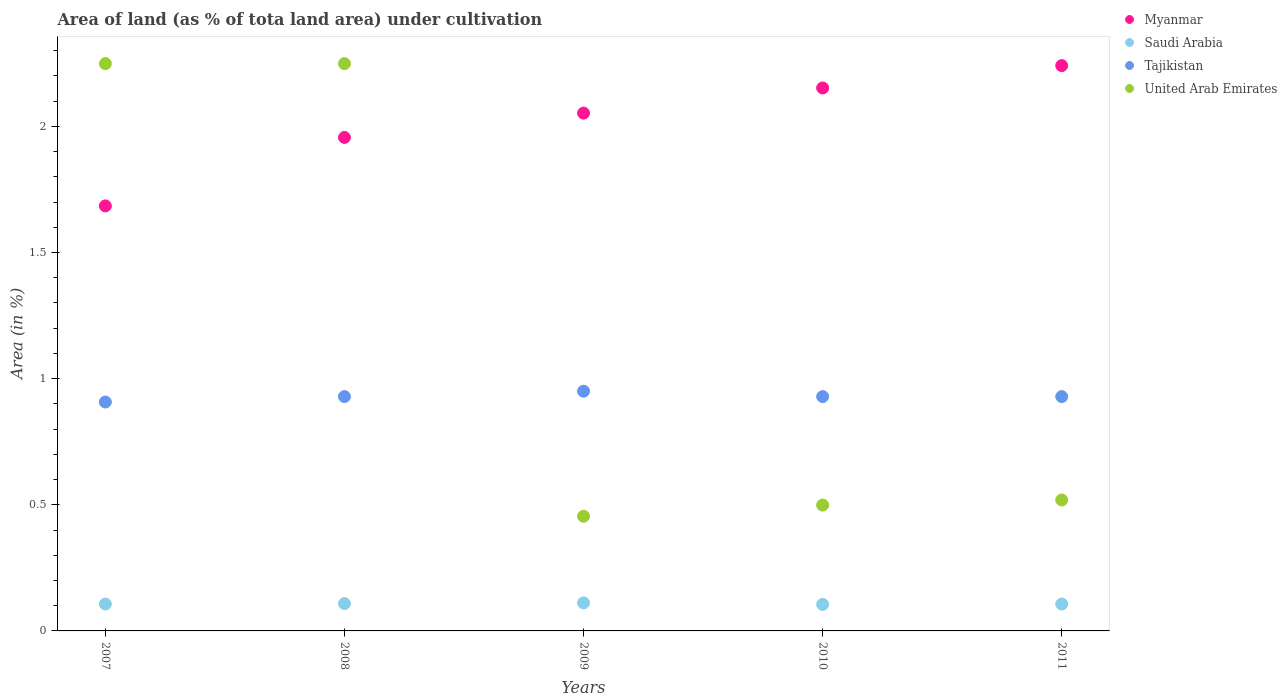What is the percentage of land under cultivation in Myanmar in 2011?
Make the answer very short. 2.24. Across all years, what is the maximum percentage of land under cultivation in Tajikistan?
Your response must be concise. 0.95. Across all years, what is the minimum percentage of land under cultivation in Saudi Arabia?
Make the answer very short. 0.11. In which year was the percentage of land under cultivation in Myanmar minimum?
Ensure brevity in your answer.  2007. What is the total percentage of land under cultivation in Tajikistan in the graph?
Keep it short and to the point. 4.64. What is the difference between the percentage of land under cultivation in Myanmar in 2008 and that in 2010?
Give a very brief answer. -0.2. What is the difference between the percentage of land under cultivation in Tajikistan in 2010 and the percentage of land under cultivation in United Arab Emirates in 2007?
Offer a very short reply. -1.32. What is the average percentage of land under cultivation in Tajikistan per year?
Offer a terse response. 0.93. In the year 2007, what is the difference between the percentage of land under cultivation in United Arab Emirates and percentage of land under cultivation in Myanmar?
Your answer should be very brief. 0.56. In how many years, is the percentage of land under cultivation in Saudi Arabia greater than 1.3 %?
Provide a succinct answer. 0. What is the ratio of the percentage of land under cultivation in Saudi Arabia in 2008 to that in 2011?
Give a very brief answer. 1.02. What is the difference between the highest and the second highest percentage of land under cultivation in Tajikistan?
Make the answer very short. 0.02. What is the difference between the highest and the lowest percentage of land under cultivation in Tajikistan?
Your response must be concise. 0.04. In how many years, is the percentage of land under cultivation in Saudi Arabia greater than the average percentage of land under cultivation in Saudi Arabia taken over all years?
Provide a short and direct response. 2. Is the sum of the percentage of land under cultivation in United Arab Emirates in 2009 and 2011 greater than the maximum percentage of land under cultivation in Myanmar across all years?
Give a very brief answer. No. Is it the case that in every year, the sum of the percentage of land under cultivation in Tajikistan and percentage of land under cultivation in Saudi Arabia  is greater than the sum of percentage of land under cultivation in United Arab Emirates and percentage of land under cultivation in Myanmar?
Your answer should be very brief. No. Is the percentage of land under cultivation in Myanmar strictly less than the percentage of land under cultivation in Saudi Arabia over the years?
Ensure brevity in your answer.  No. How many years are there in the graph?
Keep it short and to the point. 5. Are the values on the major ticks of Y-axis written in scientific E-notation?
Offer a terse response. No. Where does the legend appear in the graph?
Ensure brevity in your answer.  Top right. How many legend labels are there?
Your answer should be very brief. 4. How are the legend labels stacked?
Your response must be concise. Vertical. What is the title of the graph?
Ensure brevity in your answer.  Area of land (as % of tota land area) under cultivation. What is the label or title of the Y-axis?
Keep it short and to the point. Area (in %). What is the Area (in %) in Myanmar in 2007?
Your response must be concise. 1.68. What is the Area (in %) of Saudi Arabia in 2007?
Your response must be concise. 0.11. What is the Area (in %) in Tajikistan in 2007?
Keep it short and to the point. 0.91. What is the Area (in %) of United Arab Emirates in 2007?
Ensure brevity in your answer.  2.25. What is the Area (in %) of Myanmar in 2008?
Ensure brevity in your answer.  1.96. What is the Area (in %) in Saudi Arabia in 2008?
Give a very brief answer. 0.11. What is the Area (in %) in Tajikistan in 2008?
Your answer should be compact. 0.93. What is the Area (in %) of United Arab Emirates in 2008?
Your response must be concise. 2.25. What is the Area (in %) in Myanmar in 2009?
Provide a succinct answer. 2.05. What is the Area (in %) in Saudi Arabia in 2009?
Give a very brief answer. 0.11. What is the Area (in %) of Tajikistan in 2009?
Provide a short and direct response. 0.95. What is the Area (in %) in United Arab Emirates in 2009?
Your response must be concise. 0.45. What is the Area (in %) in Myanmar in 2010?
Offer a very short reply. 2.15. What is the Area (in %) of Saudi Arabia in 2010?
Make the answer very short. 0.11. What is the Area (in %) of Tajikistan in 2010?
Offer a very short reply. 0.93. What is the Area (in %) in United Arab Emirates in 2010?
Offer a very short reply. 0.5. What is the Area (in %) in Myanmar in 2011?
Your answer should be compact. 2.24. What is the Area (in %) in Saudi Arabia in 2011?
Offer a terse response. 0.11. What is the Area (in %) in Tajikistan in 2011?
Your response must be concise. 0.93. What is the Area (in %) of United Arab Emirates in 2011?
Provide a succinct answer. 0.52. Across all years, what is the maximum Area (in %) of Myanmar?
Offer a very short reply. 2.24. Across all years, what is the maximum Area (in %) of Saudi Arabia?
Give a very brief answer. 0.11. Across all years, what is the maximum Area (in %) of Tajikistan?
Offer a very short reply. 0.95. Across all years, what is the maximum Area (in %) in United Arab Emirates?
Your response must be concise. 2.25. Across all years, what is the minimum Area (in %) in Myanmar?
Your answer should be very brief. 1.68. Across all years, what is the minimum Area (in %) in Saudi Arabia?
Your answer should be compact. 0.11. Across all years, what is the minimum Area (in %) of Tajikistan?
Offer a terse response. 0.91. Across all years, what is the minimum Area (in %) in United Arab Emirates?
Offer a very short reply. 0.45. What is the total Area (in %) of Myanmar in the graph?
Your answer should be compact. 10.09. What is the total Area (in %) in Saudi Arabia in the graph?
Provide a succinct answer. 0.54. What is the total Area (in %) of Tajikistan in the graph?
Offer a very short reply. 4.64. What is the total Area (in %) in United Arab Emirates in the graph?
Offer a very short reply. 5.97. What is the difference between the Area (in %) of Myanmar in 2007 and that in 2008?
Your response must be concise. -0.27. What is the difference between the Area (in %) in Saudi Arabia in 2007 and that in 2008?
Ensure brevity in your answer.  -0. What is the difference between the Area (in %) in Tajikistan in 2007 and that in 2008?
Your answer should be compact. -0.02. What is the difference between the Area (in %) in Myanmar in 2007 and that in 2009?
Offer a very short reply. -0.37. What is the difference between the Area (in %) of Saudi Arabia in 2007 and that in 2009?
Provide a succinct answer. -0. What is the difference between the Area (in %) of Tajikistan in 2007 and that in 2009?
Make the answer very short. -0.04. What is the difference between the Area (in %) in United Arab Emirates in 2007 and that in 2009?
Make the answer very short. 1.79. What is the difference between the Area (in %) in Myanmar in 2007 and that in 2010?
Provide a short and direct response. -0.47. What is the difference between the Area (in %) in Saudi Arabia in 2007 and that in 2010?
Provide a short and direct response. 0. What is the difference between the Area (in %) of Tajikistan in 2007 and that in 2010?
Give a very brief answer. -0.02. What is the difference between the Area (in %) of United Arab Emirates in 2007 and that in 2010?
Keep it short and to the point. 1.75. What is the difference between the Area (in %) of Myanmar in 2007 and that in 2011?
Ensure brevity in your answer.  -0.56. What is the difference between the Area (in %) in Saudi Arabia in 2007 and that in 2011?
Ensure brevity in your answer.  0. What is the difference between the Area (in %) in Tajikistan in 2007 and that in 2011?
Ensure brevity in your answer.  -0.02. What is the difference between the Area (in %) of United Arab Emirates in 2007 and that in 2011?
Provide a succinct answer. 1.73. What is the difference between the Area (in %) of Myanmar in 2008 and that in 2009?
Give a very brief answer. -0.1. What is the difference between the Area (in %) in Saudi Arabia in 2008 and that in 2009?
Your answer should be very brief. -0. What is the difference between the Area (in %) of Tajikistan in 2008 and that in 2009?
Offer a terse response. -0.02. What is the difference between the Area (in %) in United Arab Emirates in 2008 and that in 2009?
Provide a short and direct response. 1.79. What is the difference between the Area (in %) of Myanmar in 2008 and that in 2010?
Offer a terse response. -0.2. What is the difference between the Area (in %) of Saudi Arabia in 2008 and that in 2010?
Your answer should be very brief. 0. What is the difference between the Area (in %) in Myanmar in 2008 and that in 2011?
Your response must be concise. -0.28. What is the difference between the Area (in %) in Saudi Arabia in 2008 and that in 2011?
Ensure brevity in your answer.  0. What is the difference between the Area (in %) of United Arab Emirates in 2008 and that in 2011?
Provide a succinct answer. 1.73. What is the difference between the Area (in %) in Myanmar in 2009 and that in 2010?
Ensure brevity in your answer.  -0.1. What is the difference between the Area (in %) of Saudi Arabia in 2009 and that in 2010?
Your answer should be very brief. 0.01. What is the difference between the Area (in %) of Tajikistan in 2009 and that in 2010?
Your response must be concise. 0.02. What is the difference between the Area (in %) in United Arab Emirates in 2009 and that in 2010?
Ensure brevity in your answer.  -0.04. What is the difference between the Area (in %) of Myanmar in 2009 and that in 2011?
Offer a terse response. -0.19. What is the difference between the Area (in %) in Saudi Arabia in 2009 and that in 2011?
Give a very brief answer. 0. What is the difference between the Area (in %) of Tajikistan in 2009 and that in 2011?
Offer a terse response. 0.02. What is the difference between the Area (in %) of United Arab Emirates in 2009 and that in 2011?
Make the answer very short. -0.06. What is the difference between the Area (in %) of Myanmar in 2010 and that in 2011?
Give a very brief answer. -0.09. What is the difference between the Area (in %) in Saudi Arabia in 2010 and that in 2011?
Provide a succinct answer. -0. What is the difference between the Area (in %) of Tajikistan in 2010 and that in 2011?
Offer a terse response. 0. What is the difference between the Area (in %) of United Arab Emirates in 2010 and that in 2011?
Your answer should be compact. -0.02. What is the difference between the Area (in %) of Myanmar in 2007 and the Area (in %) of Saudi Arabia in 2008?
Keep it short and to the point. 1.58. What is the difference between the Area (in %) in Myanmar in 2007 and the Area (in %) in Tajikistan in 2008?
Ensure brevity in your answer.  0.76. What is the difference between the Area (in %) in Myanmar in 2007 and the Area (in %) in United Arab Emirates in 2008?
Give a very brief answer. -0.56. What is the difference between the Area (in %) in Saudi Arabia in 2007 and the Area (in %) in Tajikistan in 2008?
Keep it short and to the point. -0.82. What is the difference between the Area (in %) of Saudi Arabia in 2007 and the Area (in %) of United Arab Emirates in 2008?
Give a very brief answer. -2.14. What is the difference between the Area (in %) of Tajikistan in 2007 and the Area (in %) of United Arab Emirates in 2008?
Give a very brief answer. -1.34. What is the difference between the Area (in %) in Myanmar in 2007 and the Area (in %) in Saudi Arabia in 2009?
Your response must be concise. 1.57. What is the difference between the Area (in %) of Myanmar in 2007 and the Area (in %) of Tajikistan in 2009?
Your answer should be compact. 0.73. What is the difference between the Area (in %) of Myanmar in 2007 and the Area (in %) of United Arab Emirates in 2009?
Your answer should be very brief. 1.23. What is the difference between the Area (in %) of Saudi Arabia in 2007 and the Area (in %) of Tajikistan in 2009?
Keep it short and to the point. -0.84. What is the difference between the Area (in %) of Saudi Arabia in 2007 and the Area (in %) of United Arab Emirates in 2009?
Provide a succinct answer. -0.35. What is the difference between the Area (in %) in Tajikistan in 2007 and the Area (in %) in United Arab Emirates in 2009?
Offer a very short reply. 0.45. What is the difference between the Area (in %) of Myanmar in 2007 and the Area (in %) of Saudi Arabia in 2010?
Offer a terse response. 1.58. What is the difference between the Area (in %) in Myanmar in 2007 and the Area (in %) in Tajikistan in 2010?
Your answer should be compact. 0.76. What is the difference between the Area (in %) in Myanmar in 2007 and the Area (in %) in United Arab Emirates in 2010?
Provide a succinct answer. 1.19. What is the difference between the Area (in %) of Saudi Arabia in 2007 and the Area (in %) of Tajikistan in 2010?
Offer a terse response. -0.82. What is the difference between the Area (in %) in Saudi Arabia in 2007 and the Area (in %) in United Arab Emirates in 2010?
Your response must be concise. -0.39. What is the difference between the Area (in %) of Tajikistan in 2007 and the Area (in %) of United Arab Emirates in 2010?
Your response must be concise. 0.41. What is the difference between the Area (in %) of Myanmar in 2007 and the Area (in %) of Saudi Arabia in 2011?
Keep it short and to the point. 1.58. What is the difference between the Area (in %) of Myanmar in 2007 and the Area (in %) of Tajikistan in 2011?
Your answer should be very brief. 0.76. What is the difference between the Area (in %) of Myanmar in 2007 and the Area (in %) of United Arab Emirates in 2011?
Ensure brevity in your answer.  1.17. What is the difference between the Area (in %) of Saudi Arabia in 2007 and the Area (in %) of Tajikistan in 2011?
Provide a succinct answer. -0.82. What is the difference between the Area (in %) of Saudi Arabia in 2007 and the Area (in %) of United Arab Emirates in 2011?
Make the answer very short. -0.41. What is the difference between the Area (in %) in Tajikistan in 2007 and the Area (in %) in United Arab Emirates in 2011?
Make the answer very short. 0.39. What is the difference between the Area (in %) of Myanmar in 2008 and the Area (in %) of Saudi Arabia in 2009?
Your answer should be very brief. 1.84. What is the difference between the Area (in %) in Myanmar in 2008 and the Area (in %) in Tajikistan in 2009?
Make the answer very short. 1.01. What is the difference between the Area (in %) in Myanmar in 2008 and the Area (in %) in United Arab Emirates in 2009?
Provide a succinct answer. 1.5. What is the difference between the Area (in %) in Saudi Arabia in 2008 and the Area (in %) in Tajikistan in 2009?
Provide a short and direct response. -0.84. What is the difference between the Area (in %) of Saudi Arabia in 2008 and the Area (in %) of United Arab Emirates in 2009?
Your answer should be compact. -0.35. What is the difference between the Area (in %) of Tajikistan in 2008 and the Area (in %) of United Arab Emirates in 2009?
Make the answer very short. 0.47. What is the difference between the Area (in %) of Myanmar in 2008 and the Area (in %) of Saudi Arabia in 2010?
Your answer should be very brief. 1.85. What is the difference between the Area (in %) in Myanmar in 2008 and the Area (in %) in Tajikistan in 2010?
Your answer should be compact. 1.03. What is the difference between the Area (in %) of Myanmar in 2008 and the Area (in %) of United Arab Emirates in 2010?
Offer a terse response. 1.46. What is the difference between the Area (in %) in Saudi Arabia in 2008 and the Area (in %) in Tajikistan in 2010?
Provide a succinct answer. -0.82. What is the difference between the Area (in %) of Saudi Arabia in 2008 and the Area (in %) of United Arab Emirates in 2010?
Offer a very short reply. -0.39. What is the difference between the Area (in %) in Tajikistan in 2008 and the Area (in %) in United Arab Emirates in 2010?
Ensure brevity in your answer.  0.43. What is the difference between the Area (in %) of Myanmar in 2008 and the Area (in %) of Saudi Arabia in 2011?
Offer a terse response. 1.85. What is the difference between the Area (in %) in Myanmar in 2008 and the Area (in %) in Tajikistan in 2011?
Offer a terse response. 1.03. What is the difference between the Area (in %) in Myanmar in 2008 and the Area (in %) in United Arab Emirates in 2011?
Make the answer very short. 1.44. What is the difference between the Area (in %) of Saudi Arabia in 2008 and the Area (in %) of Tajikistan in 2011?
Provide a short and direct response. -0.82. What is the difference between the Area (in %) of Saudi Arabia in 2008 and the Area (in %) of United Arab Emirates in 2011?
Ensure brevity in your answer.  -0.41. What is the difference between the Area (in %) in Tajikistan in 2008 and the Area (in %) in United Arab Emirates in 2011?
Keep it short and to the point. 0.41. What is the difference between the Area (in %) of Myanmar in 2009 and the Area (in %) of Saudi Arabia in 2010?
Make the answer very short. 1.95. What is the difference between the Area (in %) in Myanmar in 2009 and the Area (in %) in Tajikistan in 2010?
Offer a very short reply. 1.12. What is the difference between the Area (in %) of Myanmar in 2009 and the Area (in %) of United Arab Emirates in 2010?
Make the answer very short. 1.55. What is the difference between the Area (in %) in Saudi Arabia in 2009 and the Area (in %) in Tajikistan in 2010?
Provide a short and direct response. -0.82. What is the difference between the Area (in %) in Saudi Arabia in 2009 and the Area (in %) in United Arab Emirates in 2010?
Your response must be concise. -0.39. What is the difference between the Area (in %) in Tajikistan in 2009 and the Area (in %) in United Arab Emirates in 2010?
Your answer should be compact. 0.45. What is the difference between the Area (in %) of Myanmar in 2009 and the Area (in %) of Saudi Arabia in 2011?
Give a very brief answer. 1.95. What is the difference between the Area (in %) of Myanmar in 2009 and the Area (in %) of Tajikistan in 2011?
Your answer should be very brief. 1.12. What is the difference between the Area (in %) in Myanmar in 2009 and the Area (in %) in United Arab Emirates in 2011?
Ensure brevity in your answer.  1.53. What is the difference between the Area (in %) of Saudi Arabia in 2009 and the Area (in %) of Tajikistan in 2011?
Your answer should be compact. -0.82. What is the difference between the Area (in %) of Saudi Arabia in 2009 and the Area (in %) of United Arab Emirates in 2011?
Offer a terse response. -0.41. What is the difference between the Area (in %) of Tajikistan in 2009 and the Area (in %) of United Arab Emirates in 2011?
Make the answer very short. 0.43. What is the difference between the Area (in %) in Myanmar in 2010 and the Area (in %) in Saudi Arabia in 2011?
Keep it short and to the point. 2.05. What is the difference between the Area (in %) of Myanmar in 2010 and the Area (in %) of Tajikistan in 2011?
Your response must be concise. 1.22. What is the difference between the Area (in %) in Myanmar in 2010 and the Area (in %) in United Arab Emirates in 2011?
Offer a very short reply. 1.63. What is the difference between the Area (in %) of Saudi Arabia in 2010 and the Area (in %) of Tajikistan in 2011?
Your answer should be compact. -0.82. What is the difference between the Area (in %) of Saudi Arabia in 2010 and the Area (in %) of United Arab Emirates in 2011?
Offer a very short reply. -0.41. What is the difference between the Area (in %) in Tajikistan in 2010 and the Area (in %) in United Arab Emirates in 2011?
Give a very brief answer. 0.41. What is the average Area (in %) of Myanmar per year?
Provide a short and direct response. 2.02. What is the average Area (in %) in Saudi Arabia per year?
Provide a succinct answer. 0.11. What is the average Area (in %) of Tajikistan per year?
Ensure brevity in your answer.  0.93. What is the average Area (in %) of United Arab Emirates per year?
Provide a short and direct response. 1.19. In the year 2007, what is the difference between the Area (in %) in Myanmar and Area (in %) in Saudi Arabia?
Offer a terse response. 1.58. In the year 2007, what is the difference between the Area (in %) of Myanmar and Area (in %) of Tajikistan?
Offer a very short reply. 0.78. In the year 2007, what is the difference between the Area (in %) of Myanmar and Area (in %) of United Arab Emirates?
Provide a short and direct response. -0.56. In the year 2007, what is the difference between the Area (in %) in Saudi Arabia and Area (in %) in Tajikistan?
Provide a short and direct response. -0.8. In the year 2007, what is the difference between the Area (in %) of Saudi Arabia and Area (in %) of United Arab Emirates?
Provide a short and direct response. -2.14. In the year 2007, what is the difference between the Area (in %) of Tajikistan and Area (in %) of United Arab Emirates?
Make the answer very short. -1.34. In the year 2008, what is the difference between the Area (in %) in Myanmar and Area (in %) in Saudi Arabia?
Your answer should be compact. 1.85. In the year 2008, what is the difference between the Area (in %) of Myanmar and Area (in %) of Tajikistan?
Your answer should be compact. 1.03. In the year 2008, what is the difference between the Area (in %) in Myanmar and Area (in %) in United Arab Emirates?
Your answer should be compact. -0.29. In the year 2008, what is the difference between the Area (in %) in Saudi Arabia and Area (in %) in Tajikistan?
Ensure brevity in your answer.  -0.82. In the year 2008, what is the difference between the Area (in %) of Saudi Arabia and Area (in %) of United Arab Emirates?
Ensure brevity in your answer.  -2.14. In the year 2008, what is the difference between the Area (in %) in Tajikistan and Area (in %) in United Arab Emirates?
Offer a very short reply. -1.32. In the year 2009, what is the difference between the Area (in %) in Myanmar and Area (in %) in Saudi Arabia?
Provide a succinct answer. 1.94. In the year 2009, what is the difference between the Area (in %) in Myanmar and Area (in %) in Tajikistan?
Give a very brief answer. 1.1. In the year 2009, what is the difference between the Area (in %) in Myanmar and Area (in %) in United Arab Emirates?
Your answer should be compact. 1.6. In the year 2009, what is the difference between the Area (in %) of Saudi Arabia and Area (in %) of Tajikistan?
Your answer should be very brief. -0.84. In the year 2009, what is the difference between the Area (in %) in Saudi Arabia and Area (in %) in United Arab Emirates?
Make the answer very short. -0.34. In the year 2009, what is the difference between the Area (in %) in Tajikistan and Area (in %) in United Arab Emirates?
Offer a very short reply. 0.5. In the year 2010, what is the difference between the Area (in %) of Myanmar and Area (in %) of Saudi Arabia?
Your response must be concise. 2.05. In the year 2010, what is the difference between the Area (in %) in Myanmar and Area (in %) in Tajikistan?
Provide a short and direct response. 1.22. In the year 2010, what is the difference between the Area (in %) of Myanmar and Area (in %) of United Arab Emirates?
Offer a terse response. 1.65. In the year 2010, what is the difference between the Area (in %) in Saudi Arabia and Area (in %) in Tajikistan?
Give a very brief answer. -0.82. In the year 2010, what is the difference between the Area (in %) of Saudi Arabia and Area (in %) of United Arab Emirates?
Make the answer very short. -0.39. In the year 2010, what is the difference between the Area (in %) in Tajikistan and Area (in %) in United Arab Emirates?
Keep it short and to the point. 0.43. In the year 2011, what is the difference between the Area (in %) in Myanmar and Area (in %) in Saudi Arabia?
Make the answer very short. 2.13. In the year 2011, what is the difference between the Area (in %) in Myanmar and Area (in %) in Tajikistan?
Give a very brief answer. 1.31. In the year 2011, what is the difference between the Area (in %) in Myanmar and Area (in %) in United Arab Emirates?
Your response must be concise. 1.72. In the year 2011, what is the difference between the Area (in %) of Saudi Arabia and Area (in %) of Tajikistan?
Keep it short and to the point. -0.82. In the year 2011, what is the difference between the Area (in %) of Saudi Arabia and Area (in %) of United Arab Emirates?
Give a very brief answer. -0.41. In the year 2011, what is the difference between the Area (in %) in Tajikistan and Area (in %) in United Arab Emirates?
Give a very brief answer. 0.41. What is the ratio of the Area (in %) of Myanmar in 2007 to that in 2008?
Your answer should be very brief. 0.86. What is the ratio of the Area (in %) in Saudi Arabia in 2007 to that in 2008?
Keep it short and to the point. 0.98. What is the ratio of the Area (in %) in Tajikistan in 2007 to that in 2008?
Keep it short and to the point. 0.98. What is the ratio of the Area (in %) in United Arab Emirates in 2007 to that in 2008?
Your answer should be compact. 1. What is the ratio of the Area (in %) in Myanmar in 2007 to that in 2009?
Your answer should be compact. 0.82. What is the ratio of the Area (in %) in Saudi Arabia in 2007 to that in 2009?
Offer a terse response. 0.96. What is the ratio of the Area (in %) of Tajikistan in 2007 to that in 2009?
Your answer should be very brief. 0.95. What is the ratio of the Area (in %) in United Arab Emirates in 2007 to that in 2009?
Provide a short and direct response. 4.95. What is the ratio of the Area (in %) in Myanmar in 2007 to that in 2010?
Provide a short and direct response. 0.78. What is the ratio of the Area (in %) in Saudi Arabia in 2007 to that in 2010?
Your answer should be very brief. 1.01. What is the ratio of the Area (in %) of Tajikistan in 2007 to that in 2010?
Make the answer very short. 0.98. What is the ratio of the Area (in %) of United Arab Emirates in 2007 to that in 2010?
Keep it short and to the point. 4.51. What is the ratio of the Area (in %) in Myanmar in 2007 to that in 2011?
Offer a very short reply. 0.75. What is the ratio of the Area (in %) of Saudi Arabia in 2007 to that in 2011?
Give a very brief answer. 1. What is the ratio of the Area (in %) in Tajikistan in 2007 to that in 2011?
Make the answer very short. 0.98. What is the ratio of the Area (in %) of United Arab Emirates in 2007 to that in 2011?
Provide a succinct answer. 4.33. What is the ratio of the Area (in %) of Myanmar in 2008 to that in 2009?
Make the answer very short. 0.95. What is the ratio of the Area (in %) in Saudi Arabia in 2008 to that in 2009?
Provide a short and direct response. 0.97. What is the ratio of the Area (in %) in Tajikistan in 2008 to that in 2009?
Provide a succinct answer. 0.98. What is the ratio of the Area (in %) of United Arab Emirates in 2008 to that in 2009?
Your response must be concise. 4.95. What is the ratio of the Area (in %) in Myanmar in 2008 to that in 2010?
Give a very brief answer. 0.91. What is the ratio of the Area (in %) in Saudi Arabia in 2008 to that in 2010?
Give a very brief answer. 1.03. What is the ratio of the Area (in %) of United Arab Emirates in 2008 to that in 2010?
Give a very brief answer. 4.51. What is the ratio of the Area (in %) of Myanmar in 2008 to that in 2011?
Your answer should be very brief. 0.87. What is the ratio of the Area (in %) in Saudi Arabia in 2008 to that in 2011?
Provide a succinct answer. 1.02. What is the ratio of the Area (in %) of Tajikistan in 2008 to that in 2011?
Your answer should be compact. 1. What is the ratio of the Area (in %) in United Arab Emirates in 2008 to that in 2011?
Your answer should be compact. 4.33. What is the ratio of the Area (in %) in Myanmar in 2009 to that in 2010?
Provide a succinct answer. 0.95. What is the ratio of the Area (in %) in Saudi Arabia in 2009 to that in 2010?
Make the answer very short. 1.06. What is the ratio of the Area (in %) in Tajikistan in 2009 to that in 2010?
Your answer should be compact. 1.02. What is the ratio of the Area (in %) of United Arab Emirates in 2009 to that in 2010?
Give a very brief answer. 0.91. What is the ratio of the Area (in %) in Myanmar in 2009 to that in 2011?
Offer a terse response. 0.92. What is the ratio of the Area (in %) in Saudi Arabia in 2009 to that in 2011?
Make the answer very short. 1.04. What is the ratio of the Area (in %) of Tajikistan in 2009 to that in 2011?
Keep it short and to the point. 1.02. What is the ratio of the Area (in %) in United Arab Emirates in 2009 to that in 2011?
Provide a short and direct response. 0.88. What is the ratio of the Area (in %) in Myanmar in 2010 to that in 2011?
Offer a very short reply. 0.96. What is the ratio of the Area (in %) in Saudi Arabia in 2010 to that in 2011?
Give a very brief answer. 0.99. What is the ratio of the Area (in %) in United Arab Emirates in 2010 to that in 2011?
Make the answer very short. 0.96. What is the difference between the highest and the second highest Area (in %) in Myanmar?
Make the answer very short. 0.09. What is the difference between the highest and the second highest Area (in %) in Saudi Arabia?
Your answer should be very brief. 0. What is the difference between the highest and the second highest Area (in %) of Tajikistan?
Keep it short and to the point. 0.02. What is the difference between the highest and the lowest Area (in %) of Myanmar?
Provide a succinct answer. 0.56. What is the difference between the highest and the lowest Area (in %) in Saudi Arabia?
Provide a short and direct response. 0.01. What is the difference between the highest and the lowest Area (in %) of Tajikistan?
Provide a short and direct response. 0.04. What is the difference between the highest and the lowest Area (in %) of United Arab Emirates?
Your response must be concise. 1.79. 